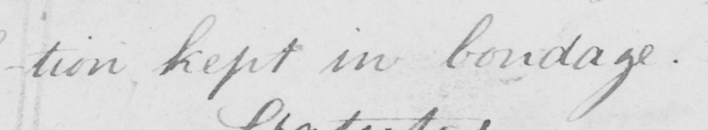Can you tell me what this handwritten text says? -tion , kept in bondage . 